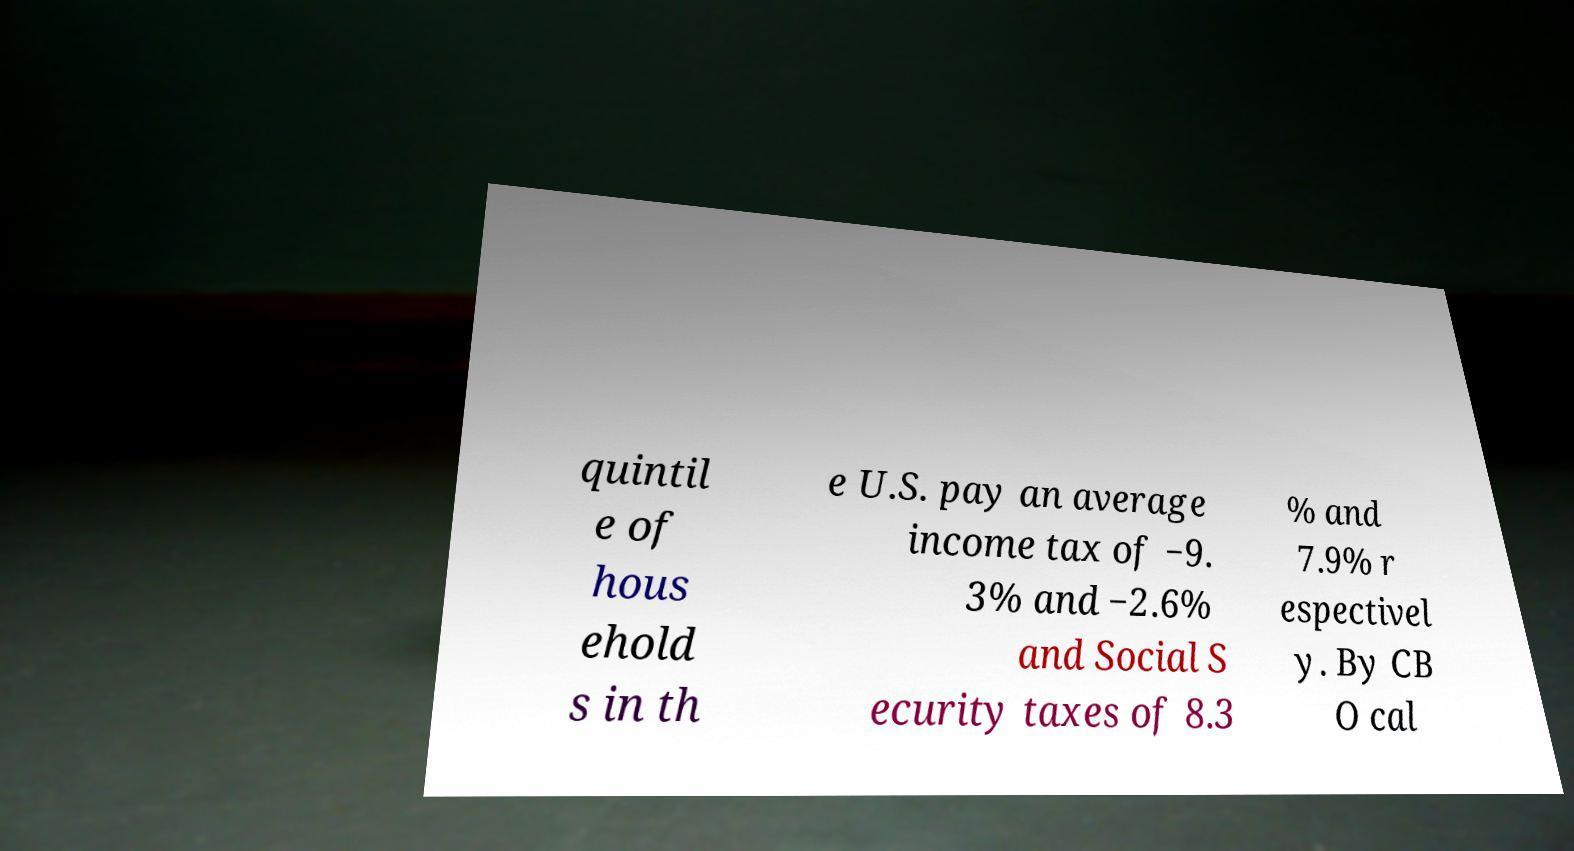Could you assist in decoding the text presented in this image and type it out clearly? quintil e of hous ehold s in th e U.S. pay an average income tax of −9. 3% and −2.6% and Social S ecurity taxes of 8.3 % and 7.9% r espectivel y. By CB O cal 